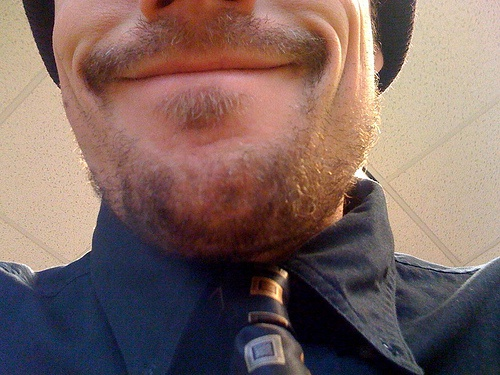Describe the objects in this image and their specific colors. I can see people in tan, black, brown, navy, and gray tones and tie in tan, black, gray, and navy tones in this image. 